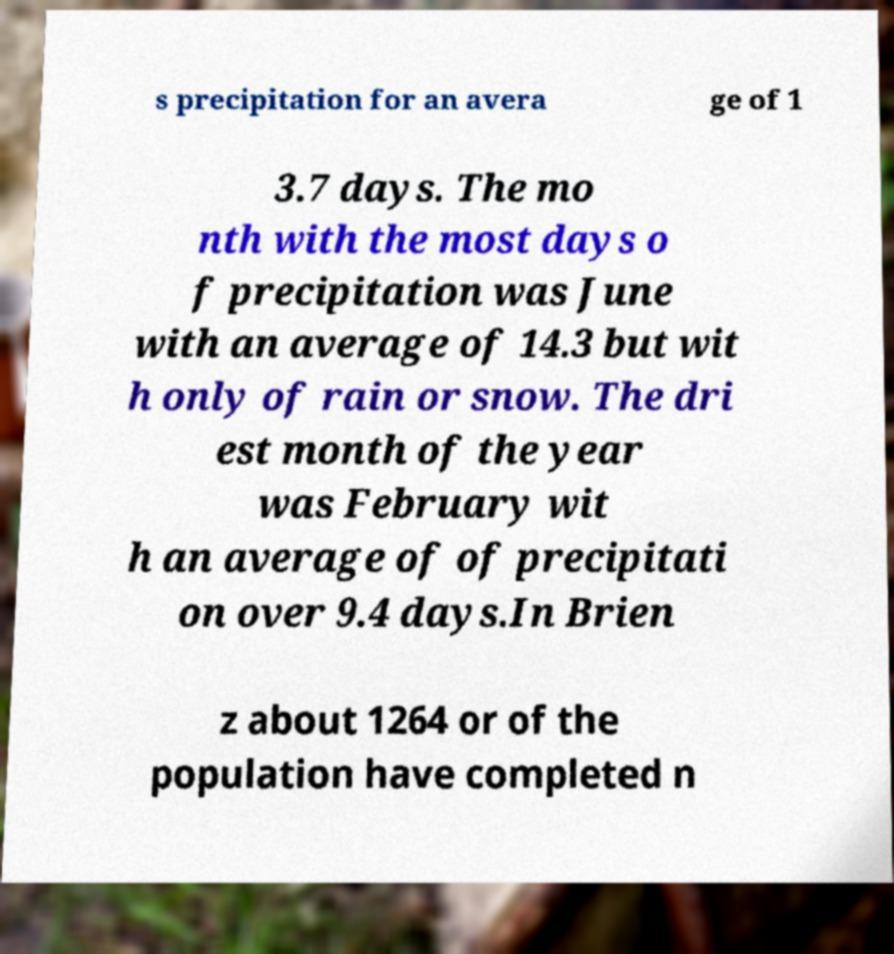Please identify and transcribe the text found in this image. s precipitation for an avera ge of 1 3.7 days. The mo nth with the most days o f precipitation was June with an average of 14.3 but wit h only of rain or snow. The dri est month of the year was February wit h an average of of precipitati on over 9.4 days.In Brien z about 1264 or of the population have completed n 